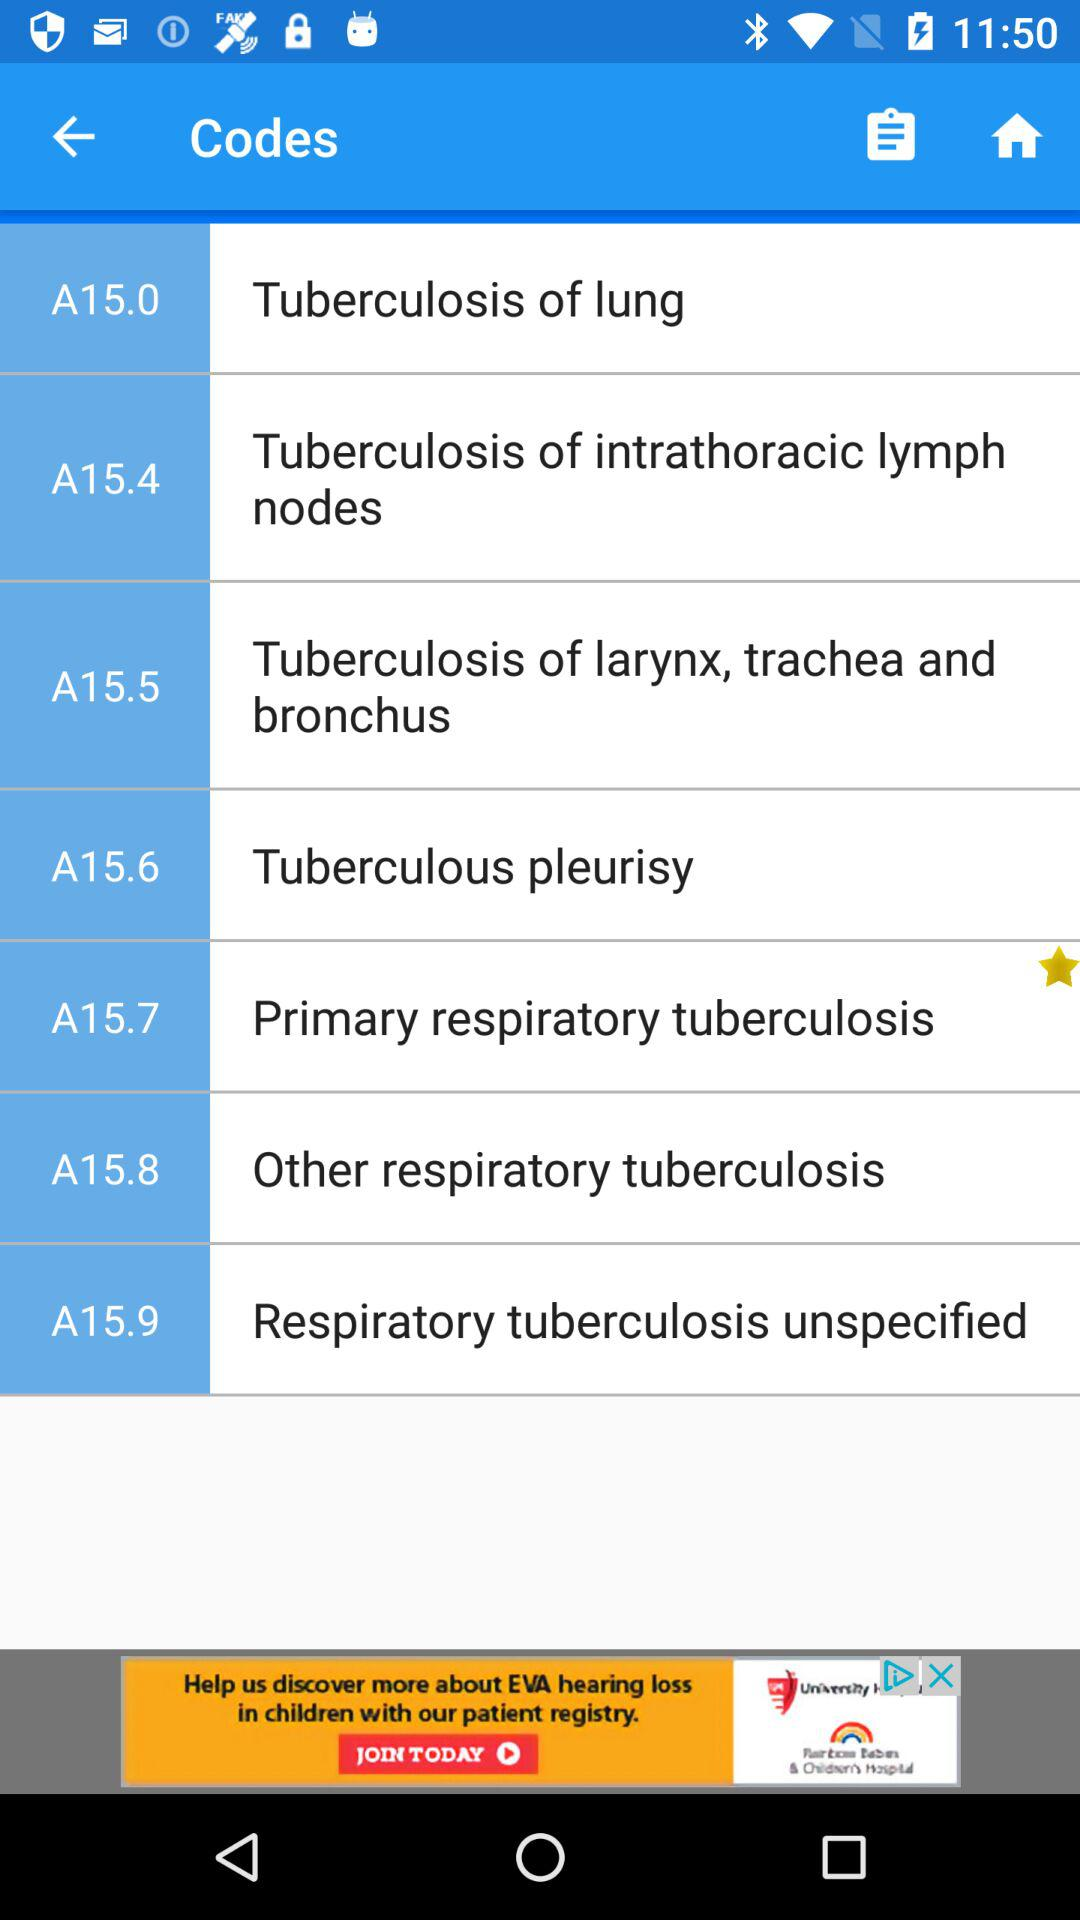What is the code for other respiratory tuberculosis? The code is A15.8. 